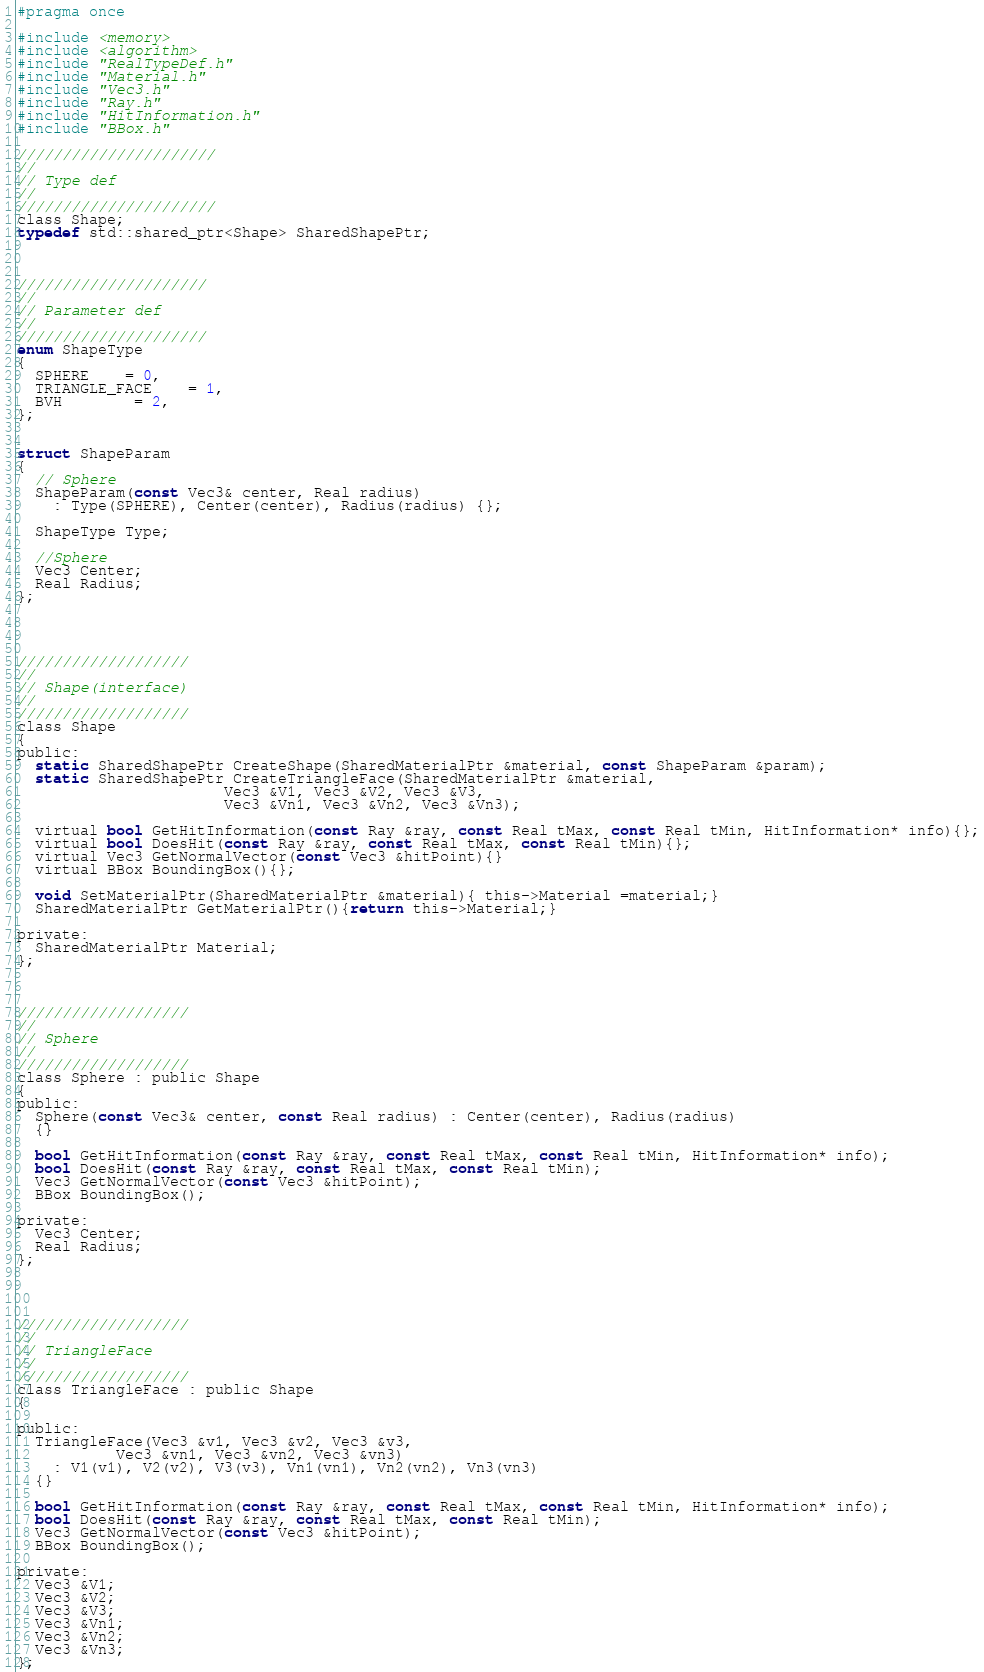Convert code to text. <code><loc_0><loc_0><loc_500><loc_500><_C_>#pragma once

#include <memory>
#include <algorithm>
#include "RealTypeDef.h"
#include "Material.h"
#include "Vec3.h"
#include "Ray.h"
#include "HitInformation.h"
#include "BBox.h"

//////////////////////
//
// Type def
//
//////////////////////
class Shape;
typedef std::shared_ptr<Shape> SharedShapePtr;



/////////////////////
//
// Parameter def
//
/////////////////////
enum ShapeType
{
  SPHERE	= 0,
  TRIANGLE_FACE	= 1,
  BVH		= 2,
};


struct ShapeParam
{
  // Sphere
  ShapeParam(const Vec3& center, Real radius)
    : Type(SPHERE), Center(center), Radius(radius) {};

  ShapeType Type;

  //Sphere
  Vec3 Center;
  Real Radius;
};




///////////////////
//
// Shape(interface)
//
///////////////////
class Shape
{
public:
  static SharedShapePtr CreateShape(SharedMaterialPtr &material, const ShapeParam &param);
  static SharedShapePtr CreateTriangleFace(SharedMaterialPtr &material,
					   Vec3 &V1, Vec3 &V2, Vec3 &V3,
					   Vec3 &Vn1, Vec3 &Vn2, Vec3 &Vn3);

  virtual bool GetHitInformation(const Ray &ray, const Real tMax, const Real tMin, HitInformation* info){};
  virtual bool DoesHit(const Ray &ray, const Real tMax, const Real tMin){};
  virtual Vec3 GetNormalVector(const Vec3 &hitPoint){}
  virtual BBox BoundingBox(){};

  void SetMaterialPtr(SharedMaterialPtr &material){ this->Material =material;}
  SharedMaterialPtr GetMaterialPtr(){return this->Material;}
  
private:
  SharedMaterialPtr Material;
};



///////////////////
//
// Sphere
//
///////////////////
class Sphere : public Shape
{
public:
  Sphere(const Vec3& center, const Real radius) : Center(center), Radius(radius)
  {}

  bool GetHitInformation(const Ray &ray, const Real tMax, const Real tMin, HitInformation* info);
  bool DoesHit(const Ray &ray, const Real tMax, const Real tMin);
  Vec3 GetNormalVector(const Vec3 &hitPoint);
  BBox BoundingBox();
  
private:
  Vec3 Center;
  Real Radius;
};




///////////////////
//
// TriangleFace
//
///////////////////
class TriangleFace : public Shape
{

public:
  TriangleFace(Vec3 &v1, Vec3 &v2, Vec3 &v3,
	       Vec3 &vn1, Vec3 &vn2, Vec3 &vn3)
    : V1(v1), V2(v2), V3(v3), Vn1(vn1), Vn2(vn2), Vn3(vn3)
  {}

  bool GetHitInformation(const Ray &ray, const Real tMax, const Real tMin, HitInformation* info);
  bool DoesHit(const Ray &ray, const Real tMax, const Real tMin);
  Vec3 GetNormalVector(const Vec3 &hitPoint);
  BBox BoundingBox();
  
private:
  Vec3 &V1;
  Vec3 &V2;
  Vec3 &V3;
  Vec3 &Vn1;
  Vec3 &Vn2;
  Vec3 &Vn3;
};
</code> 